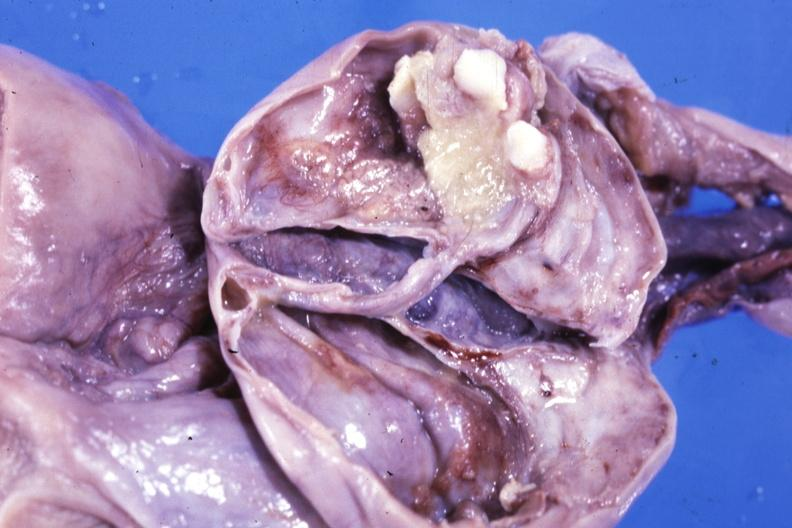s rheumatoid arthritis opened ovarian cyst with two or three teeth?
Answer the question using a single word or phrase. No 